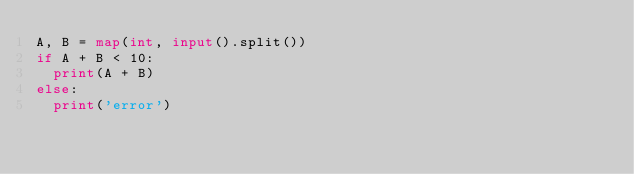Convert code to text. <code><loc_0><loc_0><loc_500><loc_500><_Python_>A, B = map(int, input().split())
if A + B < 10:
  print(A + B)
else:
  print('error')</code> 